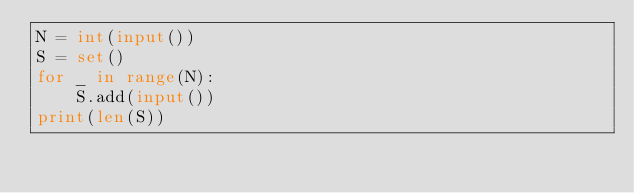<code> <loc_0><loc_0><loc_500><loc_500><_Python_>N = int(input())
S = set()
for _ in range(N):
    S.add(input())
print(len(S))</code> 